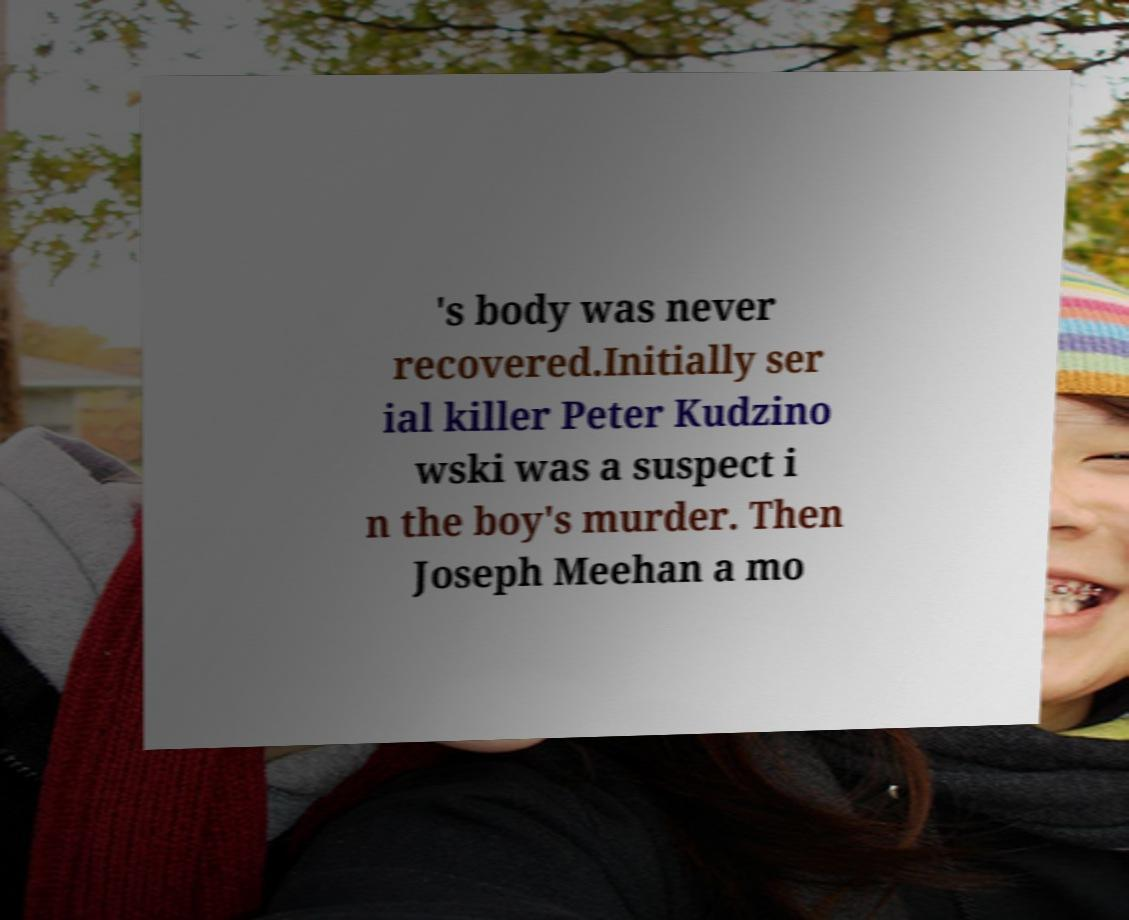Please read and relay the text visible in this image. What does it say? 's body was never recovered.Initially ser ial killer Peter Kudzino wski was a suspect i n the boy's murder. Then Joseph Meehan a mo 